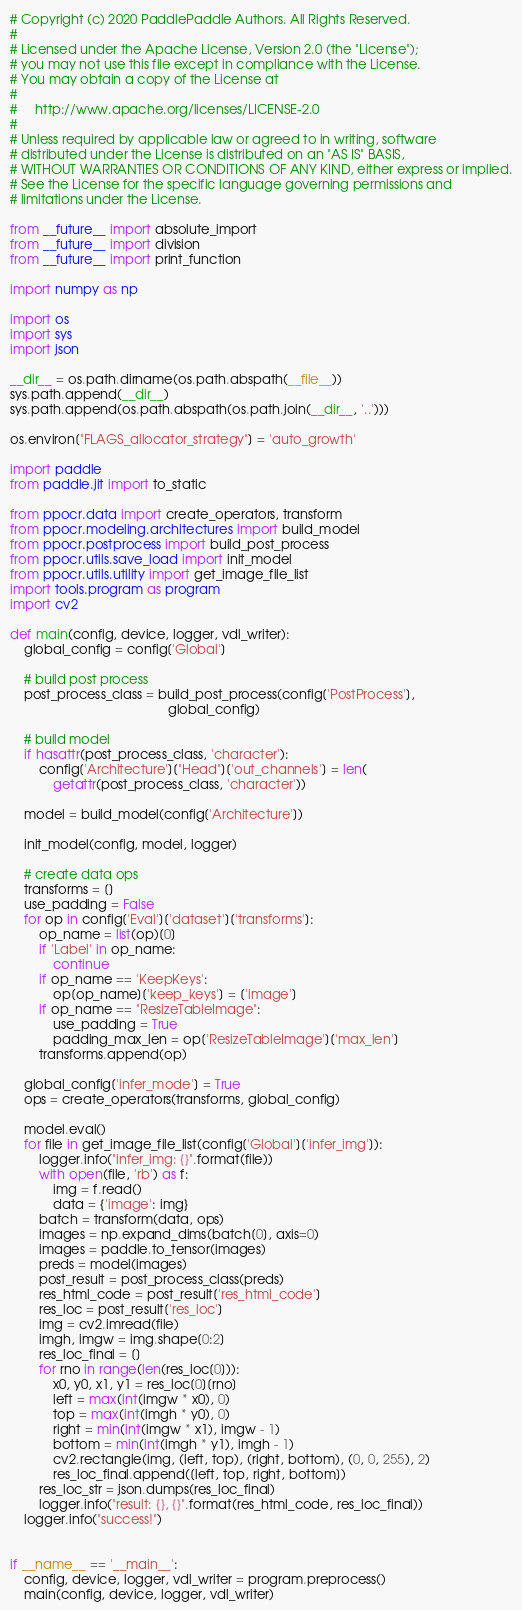<code> <loc_0><loc_0><loc_500><loc_500><_Python_># Copyright (c) 2020 PaddlePaddle Authors. All Rights Reserved.
#
# Licensed under the Apache License, Version 2.0 (the "License");
# you may not use this file except in compliance with the License.
# You may obtain a copy of the License at
#
#     http://www.apache.org/licenses/LICENSE-2.0
#
# Unless required by applicable law or agreed to in writing, software
# distributed under the License is distributed on an "AS IS" BASIS,
# WITHOUT WARRANTIES OR CONDITIONS OF ANY KIND, either express or implied.
# See the License for the specific language governing permissions and
# limitations under the License.

from __future__ import absolute_import
from __future__ import division
from __future__ import print_function

import numpy as np

import os
import sys
import json

__dir__ = os.path.dirname(os.path.abspath(__file__))
sys.path.append(__dir__)
sys.path.append(os.path.abspath(os.path.join(__dir__, '..')))

os.environ["FLAGS_allocator_strategy"] = 'auto_growth'

import paddle
from paddle.jit import to_static

from ppocr.data import create_operators, transform
from ppocr.modeling.architectures import build_model
from ppocr.postprocess import build_post_process
from ppocr.utils.save_load import init_model
from ppocr.utils.utility import get_image_file_list
import tools.program as program
import cv2

def main(config, device, logger, vdl_writer):
    global_config = config['Global']

    # build post process
    post_process_class = build_post_process(config['PostProcess'],
                                            global_config)

    # build model
    if hasattr(post_process_class, 'character'):
        config['Architecture']["Head"]['out_channels'] = len(
            getattr(post_process_class, 'character'))

    model = build_model(config['Architecture'])

    init_model(config, model, logger)

    # create data ops
    transforms = []
    use_padding = False
    for op in config['Eval']['dataset']['transforms']:
        op_name = list(op)[0]
        if 'Label' in op_name:
            continue
        if op_name == 'KeepKeys':
            op[op_name]['keep_keys'] = ['image']
        if op_name == "ResizeTableImage":
            use_padding = True
            padding_max_len = op['ResizeTableImage']['max_len']
        transforms.append(op)

    global_config['infer_mode'] = True
    ops = create_operators(transforms, global_config)

    model.eval()
    for file in get_image_file_list(config['Global']['infer_img']):
        logger.info("infer_img: {}".format(file))
        with open(file, 'rb') as f:
            img = f.read()
            data = {'image': img}
        batch = transform(data, ops)
        images = np.expand_dims(batch[0], axis=0)
        images = paddle.to_tensor(images)
        preds = model(images)
        post_result = post_process_class(preds)
        res_html_code = post_result['res_html_code']
        res_loc = post_result['res_loc']
        img = cv2.imread(file)
        imgh, imgw = img.shape[0:2]
        res_loc_final = []
        for rno in range(len(res_loc[0])):
            x0, y0, x1, y1 = res_loc[0][rno]
            left = max(int(imgw * x0), 0)
            top = max(int(imgh * y0), 0)
            right = min(int(imgw * x1), imgw - 1)
            bottom = min(int(imgh * y1), imgh - 1)
            cv2.rectangle(img, (left, top), (right, bottom), (0, 0, 255), 2)
            res_loc_final.append([left, top, right, bottom])
        res_loc_str = json.dumps(res_loc_final)
        logger.info("result: {}, {}".format(res_html_code, res_loc_final))
    logger.info("success!")


if __name__ == '__main__':
    config, device, logger, vdl_writer = program.preprocess()
    main(config, device, logger, vdl_writer)

</code> 